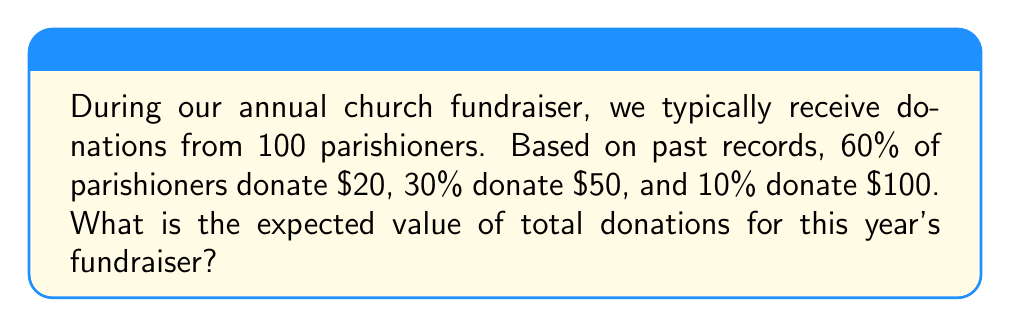Teach me how to tackle this problem. Let's approach this step-by-step:

1) First, we need to calculate the expected value of a single donation. The expected value is the sum of each possible outcome multiplied by its probability.

2) We have three possible donation amounts:
   - $20 with probability 0.60
   - $50 with probability 0.30
   - $100 with probability 0.10

3) Let's calculate the expected value of a single donation:

   $$ E(X) = 20 \cdot 0.60 + 50 \cdot 0.30 + 100 \cdot 0.10 $$

4) Simplifying:

   $$ E(X) = 12 + 15 + 10 = 37 $$

5) So, the expected value of a single donation is $37.

6) Now, since we expect 100 parishioners to donate, and each donation is independent, we can multiply our single donation expected value by 100:

   $$ \text{Total Expected Value} = 100 \cdot E(X) = 100 \cdot 37 = 3700 $$

Therefore, the expected value of total donations for this year's fundraiser is $3,700.
Answer: $3,700 